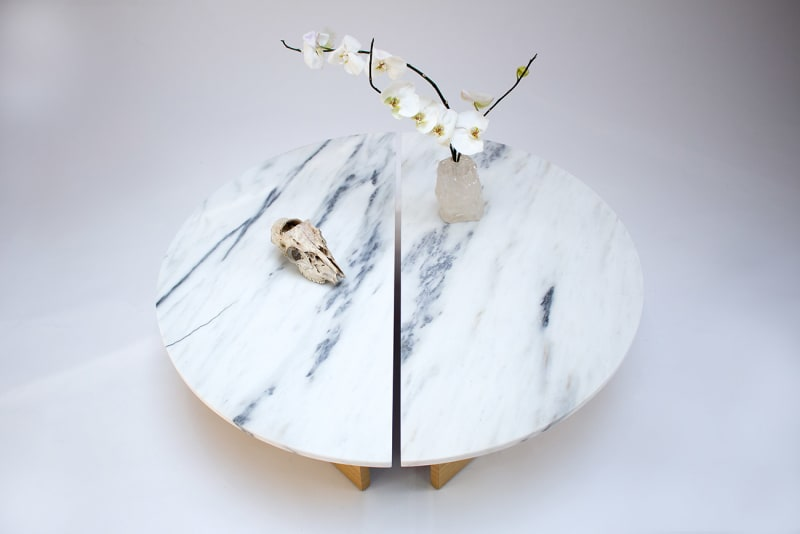Considering the items displayed on the table, what could be the underlying theme or purpose of this arrangement? The arrangement on the table suggests a theme of natural elements contrasting with the refinement of human craftsmanship. The marble table and crystal exhibit the beauty of raw materials that have been shaped to serve a purpose or to decorate a space. The orchid adds a touch of living nature, while the animal skull may represent the cycle of life and a connection to the animal kingdom. Altogether, it could indicate a decorative purpose aiming to evoke a sense of harmony between nature and human-made objects. 